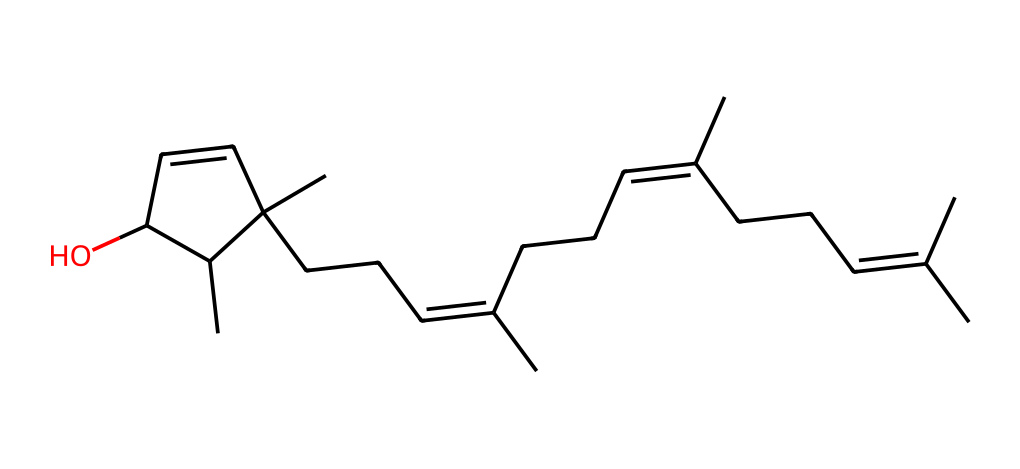what is the chemical name represented by this SMILES? The SMILES notation represents a molecule with the core structure of retinol, also known as vitamin A1, which is known for its role in skin health and rejuvenation.
Answer: retinol how many carbon atoms are in this molecular structure? By counting the 'C' in the SMILES notation and considering the structure where carbon is the main backbone of retinol, we find there are 20 carbon atoms.
Answer: 20 what type of functional group is present in this chemical structure? The presence of the hydroxyl group (–OH) indicated by the 'O' in the SMILES shows that this compound is an alcohol, specifically a primary alcohol in the case of retinol.
Answer: alcohol which part of this molecule is primarily responsible for skin rejuvenation effects? The entire structure contributes, but specifically, the hydroxyl group (which is part of the structure) interacts with skin cells to promote renewal and turnover, thus is primarily responsible for skin rejuvenation.
Answer: hydroxyl group how many double bonds are present in this structure? Observing the structure carefully, we note that there are three double bonds in retinol, which is important for its biological activity.
Answer: 3 what is the molecular formula of retinol? From the molecular structure represented by the SMILES, we can derive the molecular formula, which is C20H30O, indicating it has 20 carbon atoms, 30 hydrogen atoms, and 1 oxygen atom.
Answer: C20H30O what role does this molecule play in collagen production? Retinol enhances collagen synthesis due to its ability to transactivate retinoic acid receptors, which initiate the transcription of genes involved in collagen production, thereby improving skin elasticity and reducing wrinkles.
Answer: enhance collagen synthesis 